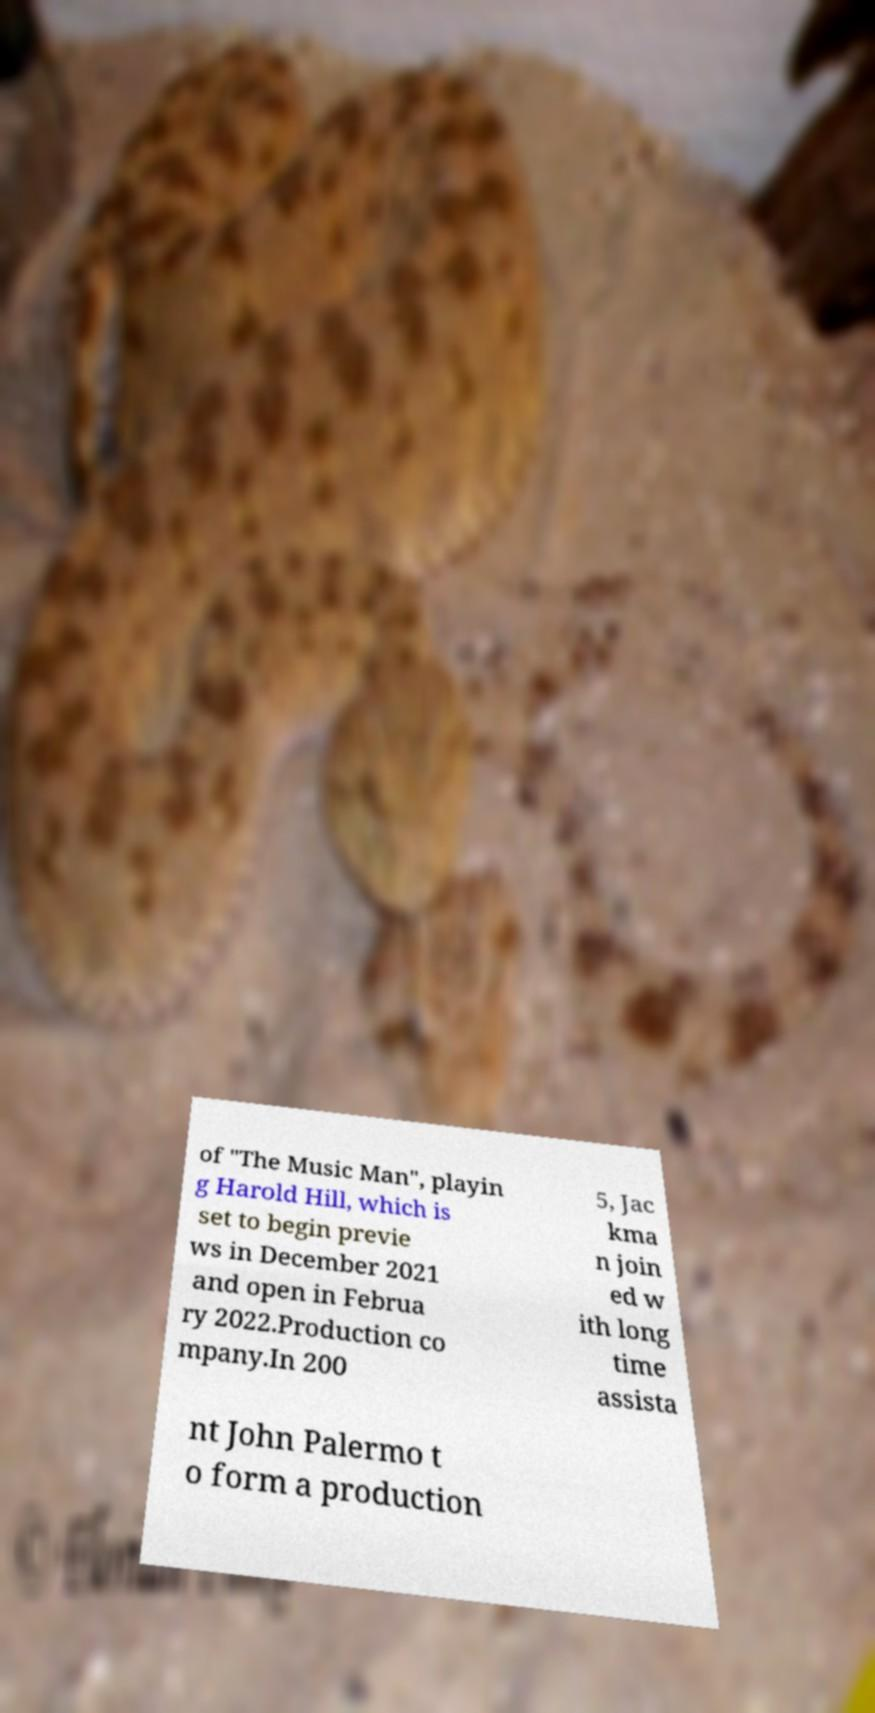There's text embedded in this image that I need extracted. Can you transcribe it verbatim? of "The Music Man", playin g Harold Hill, which is set to begin previe ws in December 2021 and open in Februa ry 2022.Production co mpany.In 200 5, Jac kma n join ed w ith long time assista nt John Palermo t o form a production 